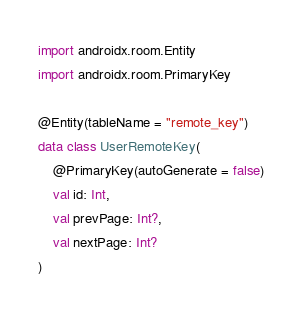Convert code to text. <code><loc_0><loc_0><loc_500><loc_500><_Kotlin_>
import androidx.room.Entity
import androidx.room.PrimaryKey

@Entity(tableName = "remote_key")
data class UserRemoteKey(
    @PrimaryKey(autoGenerate = false)
    val id: Int,
    val prevPage: Int?,
    val nextPage: Int?
)
</code> 